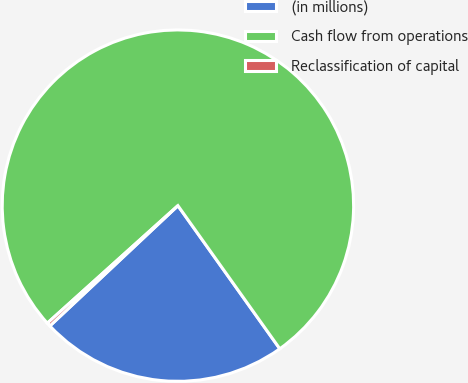<chart> <loc_0><loc_0><loc_500><loc_500><pie_chart><fcel>(in millions)<fcel>Cash flow from operations<fcel>Reclassification of capital<nl><fcel>22.84%<fcel>76.81%<fcel>0.34%<nl></chart> 